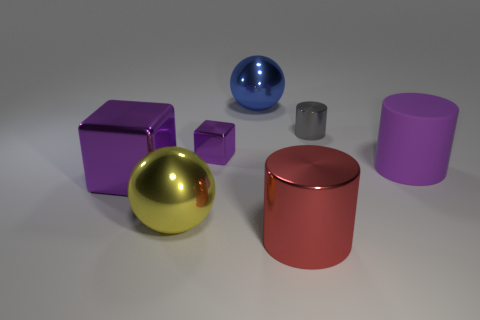Subtract 1 cylinders. How many cylinders are left? 2 Add 3 big brown metal things. How many objects exist? 10 Subtract all balls. How many objects are left? 5 Subtract 0 brown cylinders. How many objects are left? 7 Subtract all red spheres. Subtract all cubes. How many objects are left? 5 Add 2 blue metal objects. How many blue metal objects are left? 3 Add 6 gray spheres. How many gray spheres exist? 6 